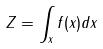<formula> <loc_0><loc_0><loc_500><loc_500>Z = \int _ { x } f ( x ) d x</formula> 